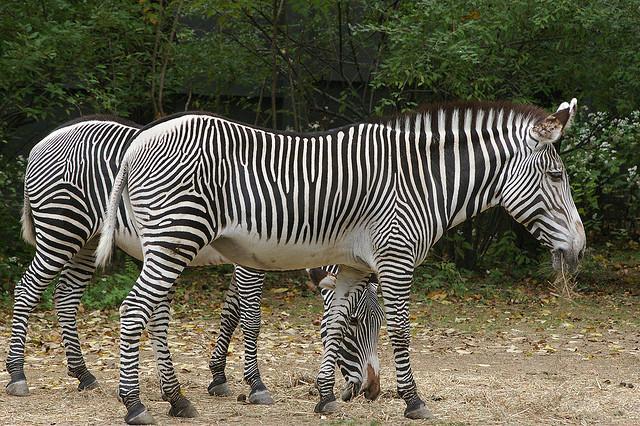How many zebras are there?
Give a very brief answer. 2. How many zebras are eating?
Give a very brief answer. 2. How many zebras are in the picture?
Give a very brief answer. 2. 